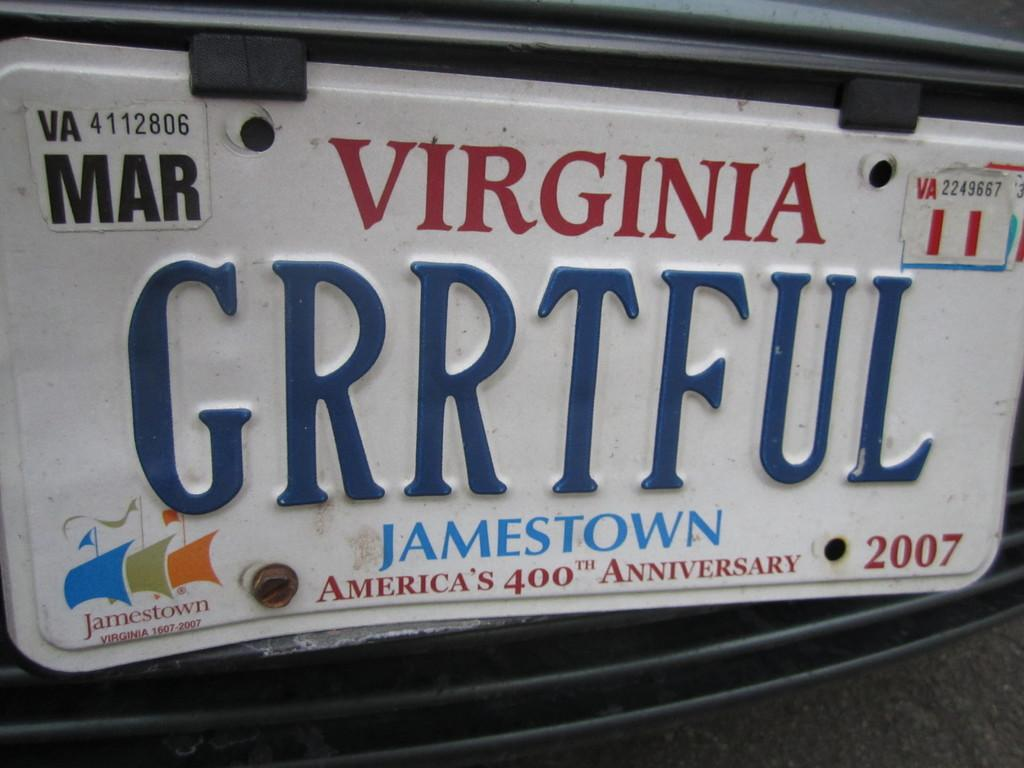<image>
Relay a brief, clear account of the picture shown. The Virginia license plate is a special one for America's 400th Anniversary at Jamestown. 